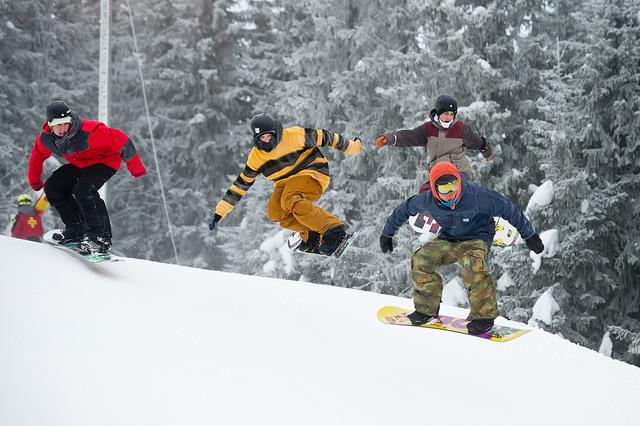The middle athlete looks like an what? bee 